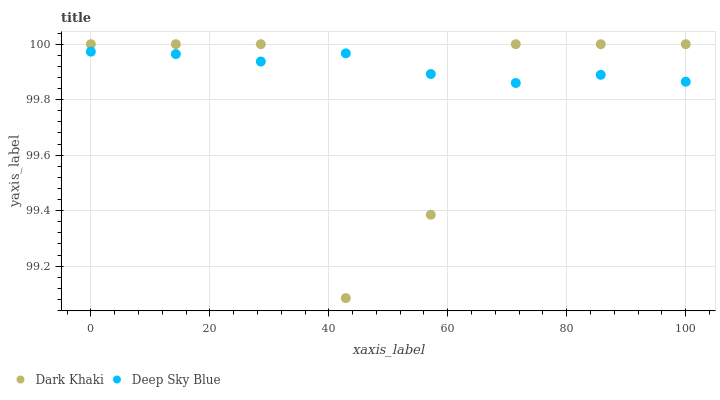Does Dark Khaki have the minimum area under the curve?
Answer yes or no. Yes. Does Deep Sky Blue have the maximum area under the curve?
Answer yes or no. Yes. Does Deep Sky Blue have the minimum area under the curve?
Answer yes or no. No. Is Deep Sky Blue the smoothest?
Answer yes or no. Yes. Is Dark Khaki the roughest?
Answer yes or no. Yes. Is Deep Sky Blue the roughest?
Answer yes or no. No. Does Dark Khaki have the lowest value?
Answer yes or no. Yes. Does Deep Sky Blue have the lowest value?
Answer yes or no. No. Does Dark Khaki have the highest value?
Answer yes or no. Yes. Does Deep Sky Blue have the highest value?
Answer yes or no. No. Does Deep Sky Blue intersect Dark Khaki?
Answer yes or no. Yes. Is Deep Sky Blue less than Dark Khaki?
Answer yes or no. No. Is Deep Sky Blue greater than Dark Khaki?
Answer yes or no. No. 